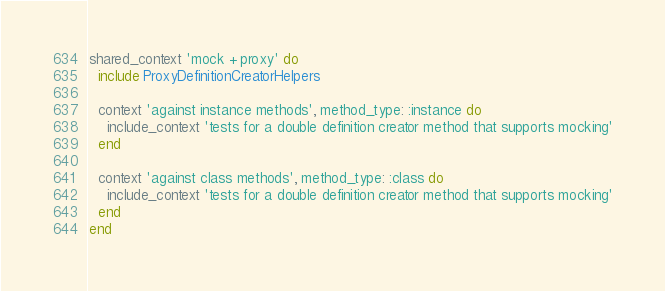Convert code to text. <code><loc_0><loc_0><loc_500><loc_500><_Ruby_>shared_context 'mock + proxy' do
  include ProxyDefinitionCreatorHelpers

  context 'against instance methods', method_type: :instance do
    include_context 'tests for a double definition creator method that supports mocking'
  end

  context 'against class methods', method_type: :class do
    include_context 'tests for a double definition creator method that supports mocking'
  end
end
</code> 